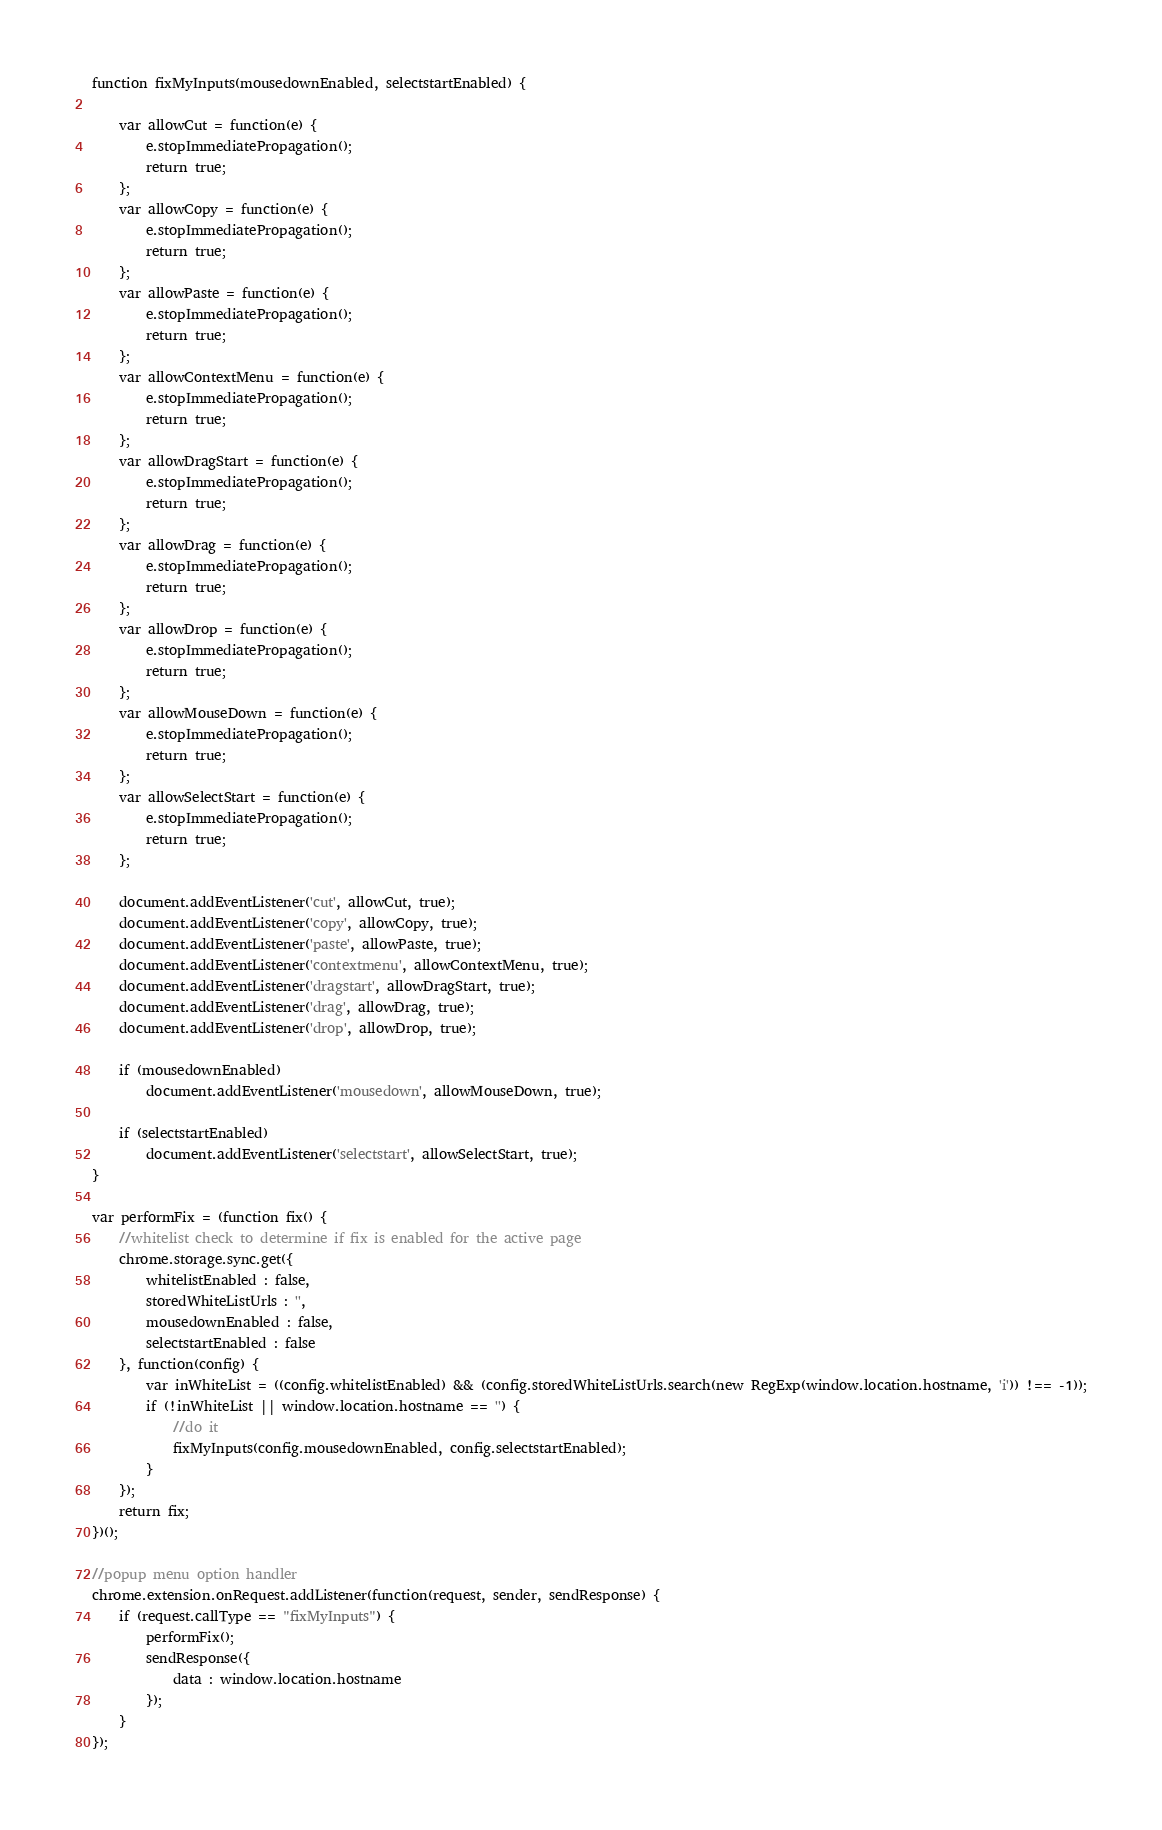Convert code to text. <code><loc_0><loc_0><loc_500><loc_500><_JavaScript_>function fixMyInputs(mousedownEnabled, selectstartEnabled) {

	var allowCut = function(e) {
		e.stopImmediatePropagation();
		return true;
	};
	var allowCopy = function(e) {
		e.stopImmediatePropagation();
		return true;
	};
	var allowPaste = function(e) {
		e.stopImmediatePropagation();
		return true;
	};
	var allowContextMenu = function(e) {
		e.stopImmediatePropagation();
		return true;
	};
	var allowDragStart = function(e) {
		e.stopImmediatePropagation();
		return true;
	};
	var allowDrag = function(e) {
		e.stopImmediatePropagation();
		return true;
	};
	var allowDrop = function(e) {
		e.stopImmediatePropagation();
		return true;
	};
	var allowMouseDown = function(e) {
		e.stopImmediatePropagation();
		return true;
	};
	var allowSelectStart = function(e) {
		e.stopImmediatePropagation();
		return true;
	};

	document.addEventListener('cut', allowCut, true);
	document.addEventListener('copy', allowCopy, true);
	document.addEventListener('paste', allowPaste, true);
	document.addEventListener('contextmenu', allowContextMenu, true);	
	document.addEventListener('dragstart', allowDragStart, true);
	document.addEventListener('drag', allowDrag, true);
	document.addEventListener('drop', allowDrop, true);
	
	if (mousedownEnabled)
		document.addEventListener('mousedown', allowMouseDown, true);
		
	if (selectstartEnabled)
		document.addEventListener('selectstart', allowSelectStart, true);
}

var performFix = (function fix() {
	//whitelist check to determine if fix is enabled for the active page
	chrome.storage.sync.get({
		whitelistEnabled : false,
		storedWhiteListUrls : '',
		mousedownEnabled : false,
		selectstartEnabled : false
	}, function(config) {
		var inWhiteList = ((config.whitelistEnabled) && (config.storedWhiteListUrls.search(new RegExp(window.location.hostname, 'i')) !== -1));
		if (!inWhiteList || window.location.hostname == '') {
			//do it
			fixMyInputs(config.mousedownEnabled, config.selectstartEnabled);
		}
	});
	return fix;
})();

//popup menu option handler
chrome.extension.onRequest.addListener(function(request, sender, sendResponse) {
	if (request.callType == "fixMyInputs") {
		performFix();
		sendResponse({
			data : window.location.hostname
		});
	}
});
</code> 